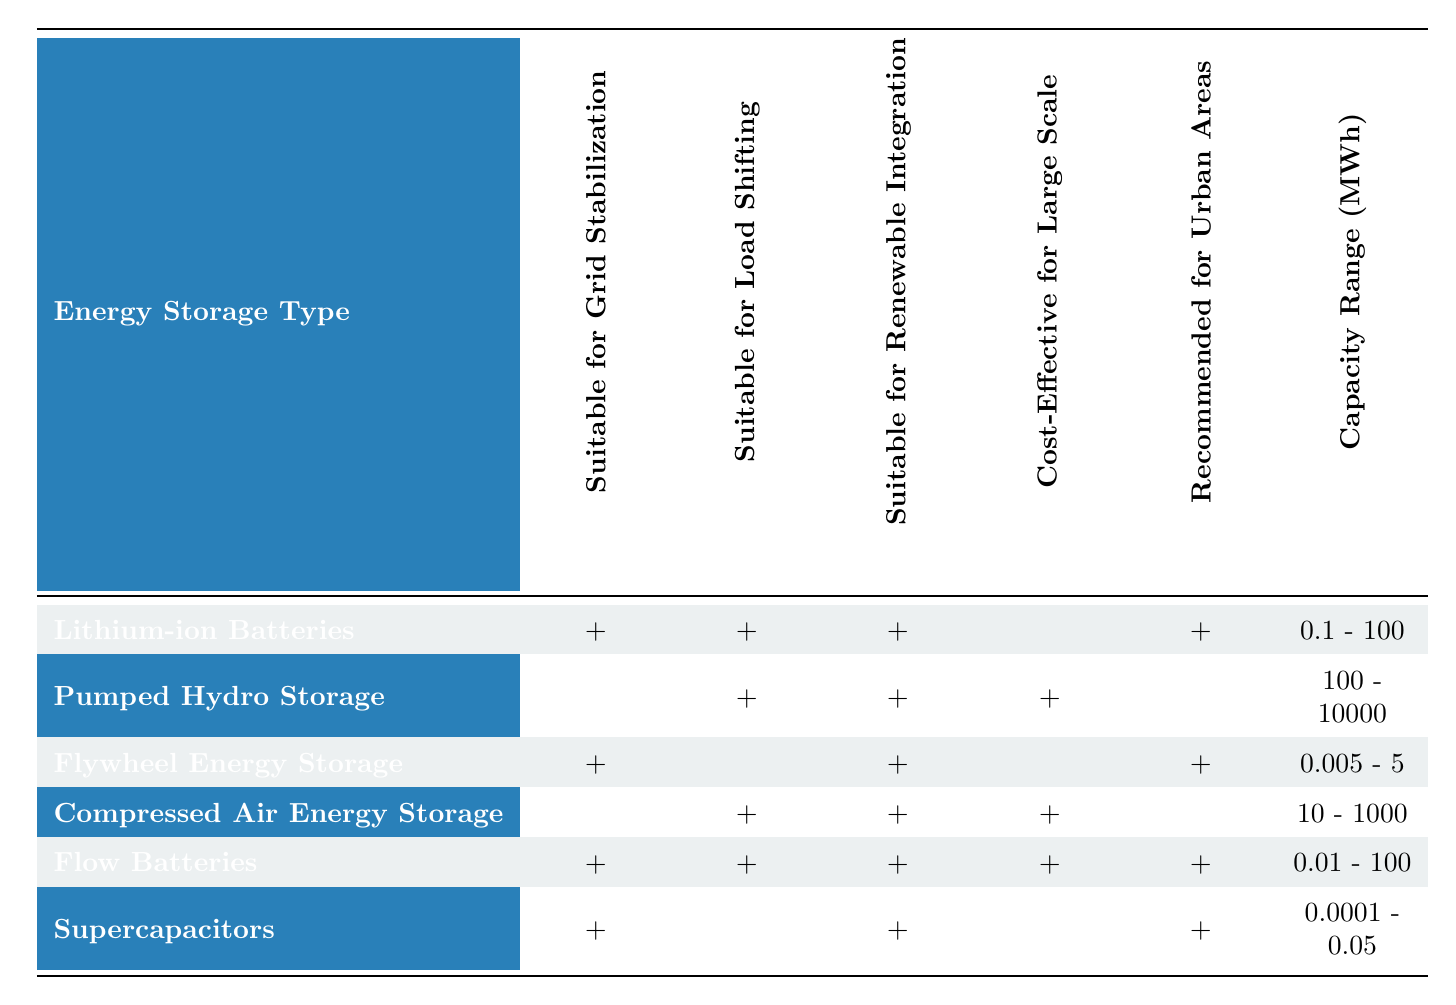What is the response time for Lithium-ion Batteries? The response time for Lithium-ion Batteries, as indicated in the table, is in milliseconds. This data can be found directly under the "Response Time" column corresponding to "Lithium-ion Batteries."
Answer: milliseconds Which energy storage type has the longest lifespan? By inspecting the "Lifespan" column, we can see that Pumped Hydro Storage has the longest lifespan (40 - 60 years) compared to the other options listed in the table.
Answer: 40 - 60 years Are Flow Batteries cost-effective for large scale applications? Looking at the "Cost-Effective for Large Scale" column for Flow Batteries, it shows that they are indeed marked as true (checkmark). Therefore, the answer is yes.
Answer: yes Which energy storage type is recommended for urban areas and has the lowest environmental impact? By analyzing the table, Flow Batteries and Supercapacitors are both recommended for urban areas, but Supercapacitors have a low environmental impact, making them the answer.
Answer: Supercapacitors How many energy storage types are suitable for renewable integration? We can count the number of checkmarks in the "Suitable for Renewable Integration" column, which shows 5 checkmarks across different energy storage types. This indicates that five types are suitable for renewable integration.
Answer: 5 What is the average lifespan of the energy storage types listed? To find the average lifespan, first gather the range values from the table: 12.5 (average of 10 - 15), 50 (average of 40 - 60), 17.5 (average of 15 - 20), 30 (average of 20 - 40), 20 (average of 15 - 25), and 15 (average of 10 - 20). Adding these averages gives 145, and dividing by 6 (the number of types) results in approximately 24.17 years.
Answer: 24.17 years Is Compressed Air Energy Storage suitable for load shifting? Checking the corresponding column for Compressed Air Energy Storage reveals a checkmark, which indicates that it is indeed suitable for load shifting.
Answer: yes Which energy storage type has the highest capacity range? Looking at the "Capacity Range" column, Pumped Hydro Storage has the highest capacity range of 100 - 10000 MWh compared to the other energy storage types.
Answer: 100 - 10000 MWh 